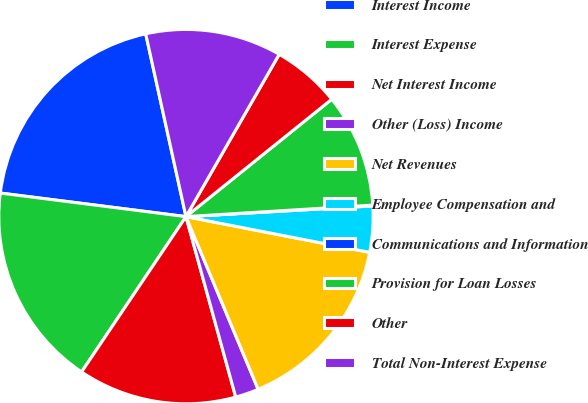<chart> <loc_0><loc_0><loc_500><loc_500><pie_chart><fcel>Interest Income<fcel>Interest Expense<fcel>Net Interest Income<fcel>Other (Loss) Income<fcel>Net Revenues<fcel>Employee Compensation and<fcel>Communications and Information<fcel>Provision for Loan Losses<fcel>Other<fcel>Total Non-Interest Expense<nl><fcel>19.54%<fcel>17.59%<fcel>13.7%<fcel>2.02%<fcel>15.64%<fcel>3.97%<fcel>0.07%<fcel>9.81%<fcel>5.91%<fcel>11.75%<nl></chart> 